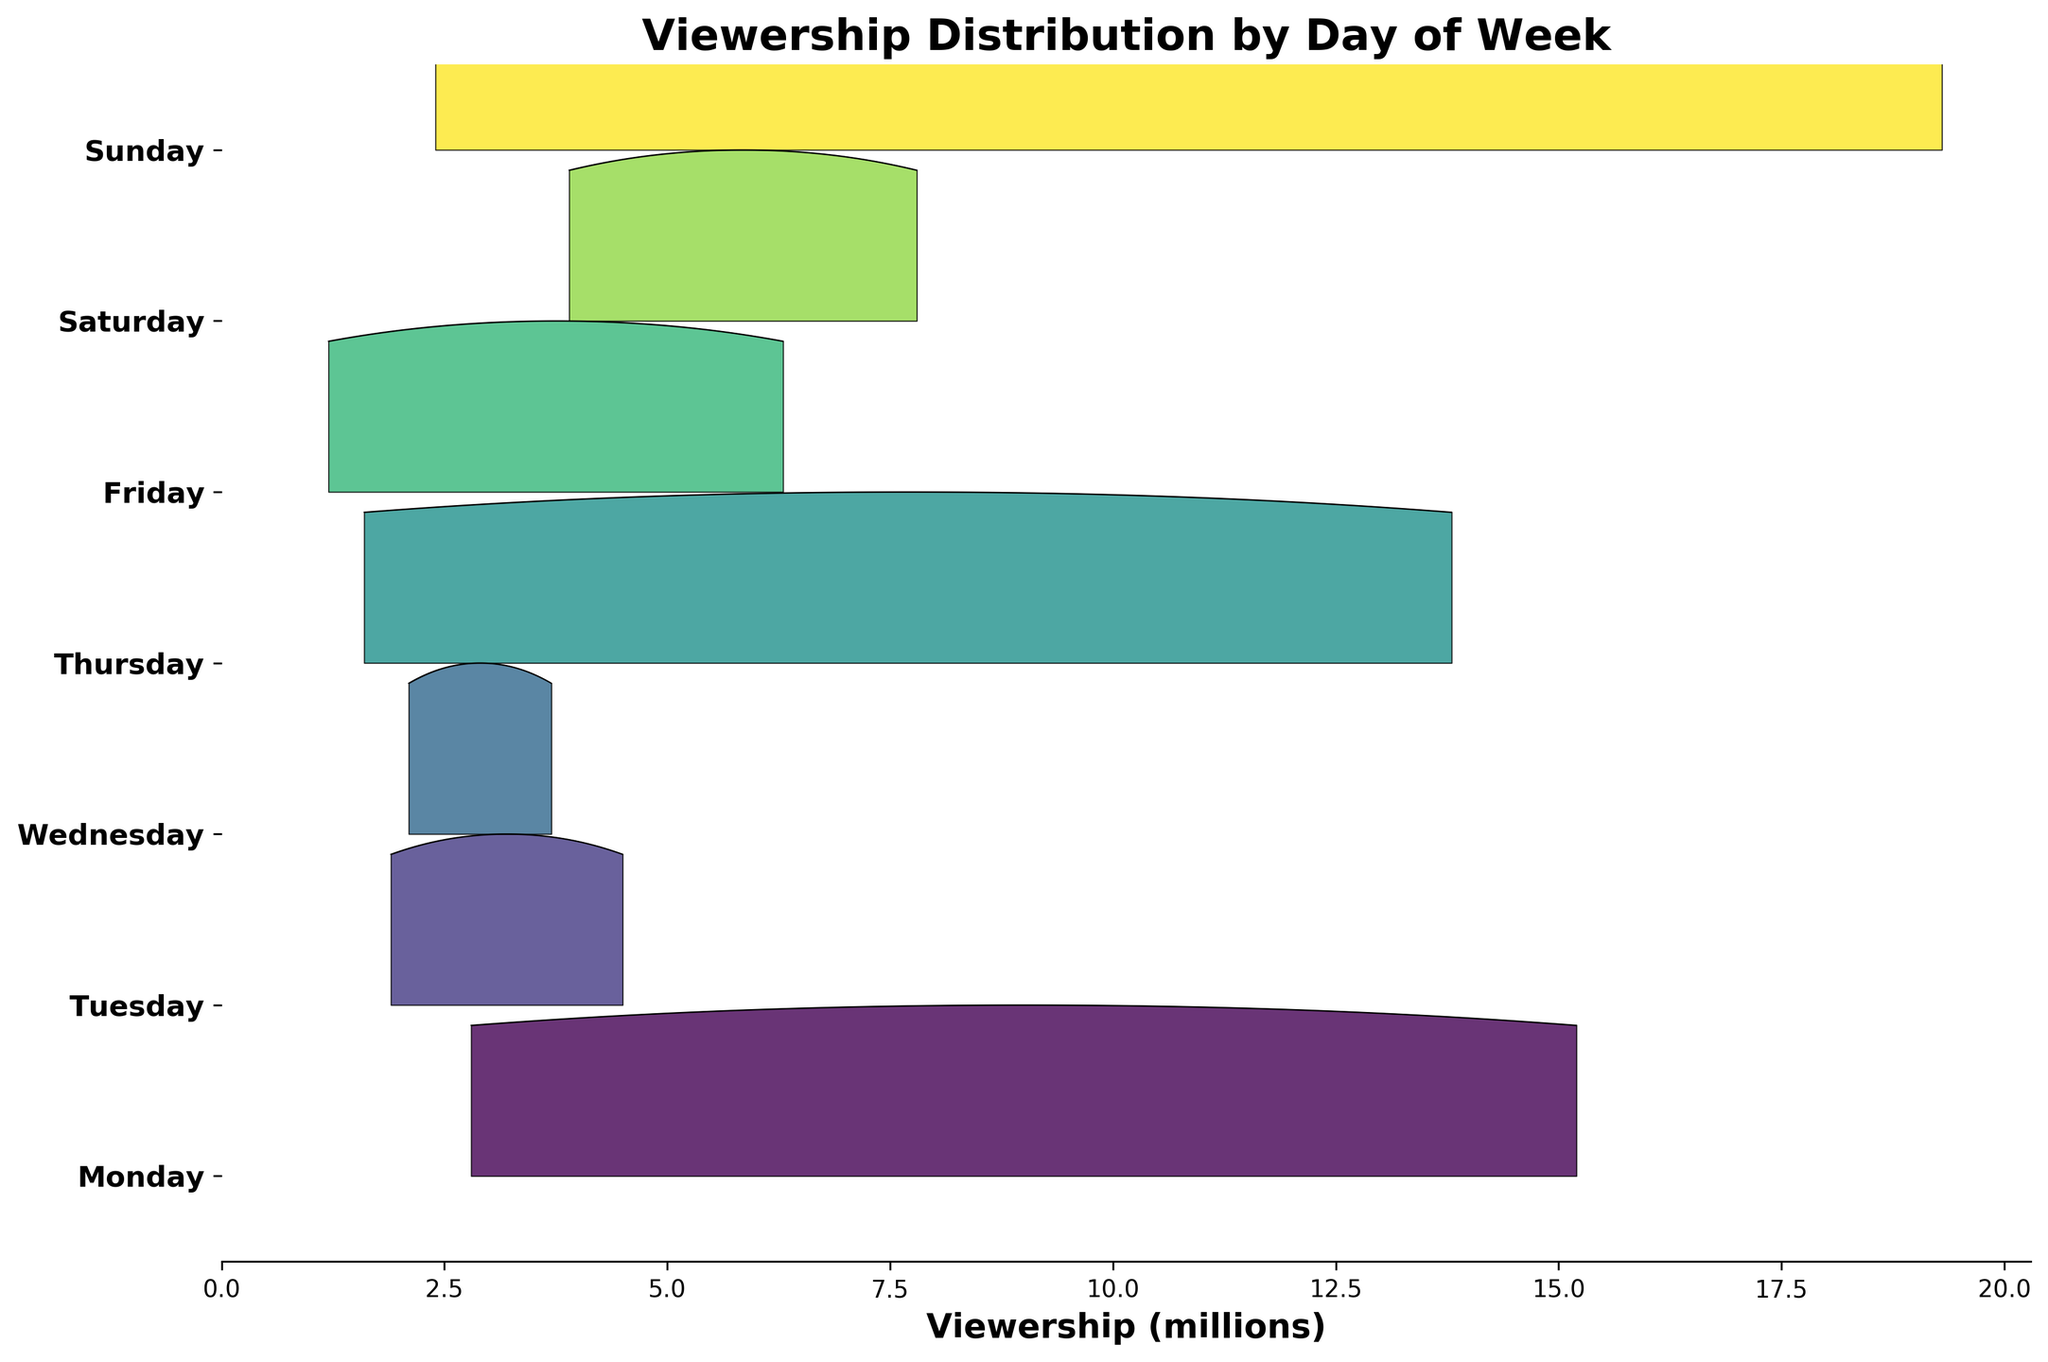What's the title of the figure? The title is prominently displayed at the top center of the figure. It helps understand the main subject of the visualization.
Answer: Viewership Distribution by Day of Week Which day of the week has the highest peak in viewership? By examining the ridgeline plot, one can notice the day with the most pronounced peak, indicating the highest density of viewership ratings.
Answer: Sunday Where does "NFL Monday Night Football" fall in terms of viewership compared to other Monday events? The ridgeline plot will show the peak viewership ratings for each event on Monday, and "NFL Monday Night Football" will correspond to the highest value in that context.
Answer: It has the highest viewership on Monday Which day has the lowest spread in viewership ratings? By observing the width of the ridgelines for each day, we can identify the day with the narrowest distribution, indicating the least variation in viewership.
Answer: Friday Compare the viewership spread for Tuesday and Thursday. Which day shows more diversity in viewership ratings? Look at the breadth of the ridgelines for both days. A wider spread indicates more diversity in viewership ratings.
Answer: Thursday What's the average viewership for events shown on Thursday? Summing up the viewership ratings for Thursday events (13.8 and 1.6) and dividing by the number of events gives the average.
Answer: (13.8 + 1.6) / 2 = 7.7 Identify the time slot with the highest viewership on Sunday. Examine the ridgeline plot for Sunday and identify which part of the day has the highest peak, indicating the time slot with the highest viewership.
Answer: Primetime Which days show a peak viewership greater than 10 million? By inspecting the peaks of the ridgelines, we can identify days whose peaks exceed the 10 million mark on the X-axis.
Answer: Monday, Thursday, Sunday Rank the weekdays from highest to lowest in terms of peak viewership. Evaluate the ridgeline peaks for each weekday and order them accordingly.
Answer: Sunday > Monday > Thursday > Friday > Saturday > Wednesday > Tuesday 